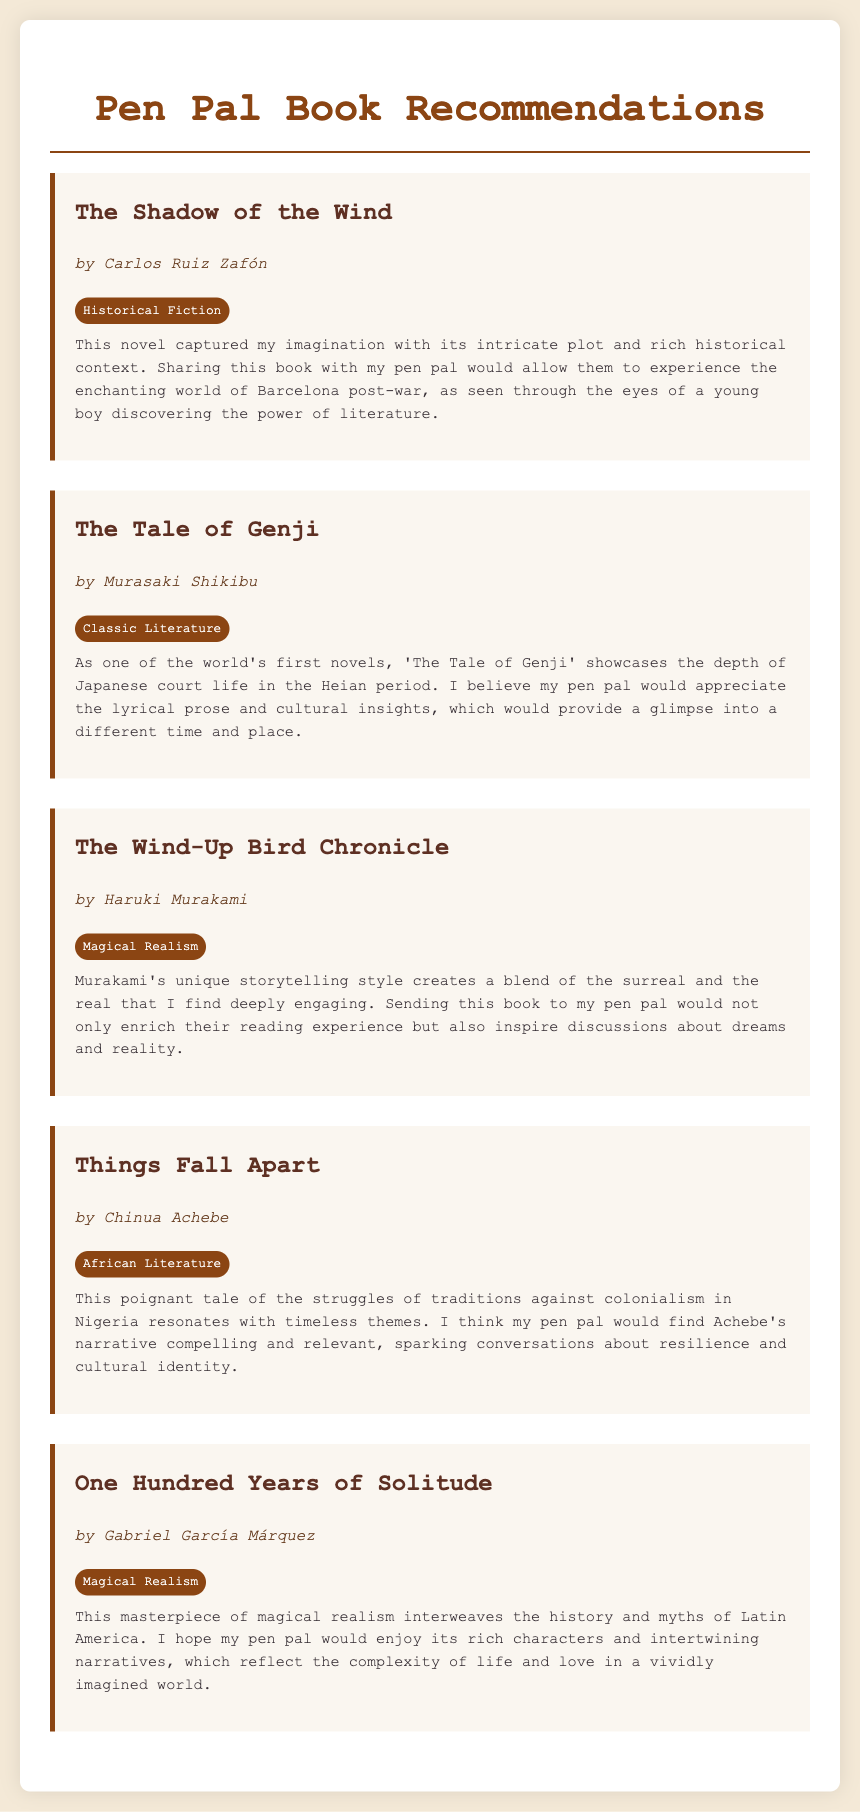What is the title of the first book? The title is listed at the top of the first book recommendation section.
Answer: The Shadow of the Wind Who is the author of "One Hundred Years of Solitude"? The author's name is specified directly beneath the book title in its section.
Answer: Gabriel García Márquez What genre does "The Tale of Genji" belong to? The genre is indicated next to the book's title and author.
Answer: Classic Literature How many books are recommended in total? The total number of book sections in the document indicates how many books are recommended.
Answer: Five Which book features magical realism and is authored by Haruki Murakami? This question requires knowledge of both the author and the genre specified in the document.
Answer: The Wind-Up Bird Chronicle What theme does Achebe's "Things Fall Apart" primarily address? The theme is outlined in the reflection section of the book, highlighting its main focus.
Answer: Colonialism What does the reflection about "The Shadow of the Wind" emphasize? The emphasis is detailed in the reflection, summarizing the main points made by the recommender.
Answer: Imagination and literature's power What city is important in "The Shadow of the Wind"? The location mentioned in the reflection provides context for the book's setting.
Answer: Barcelona Which book is considered one of the world's first novels? This is stated in the reflection section, explaining its historical significance.
Answer: The Tale of Genji 